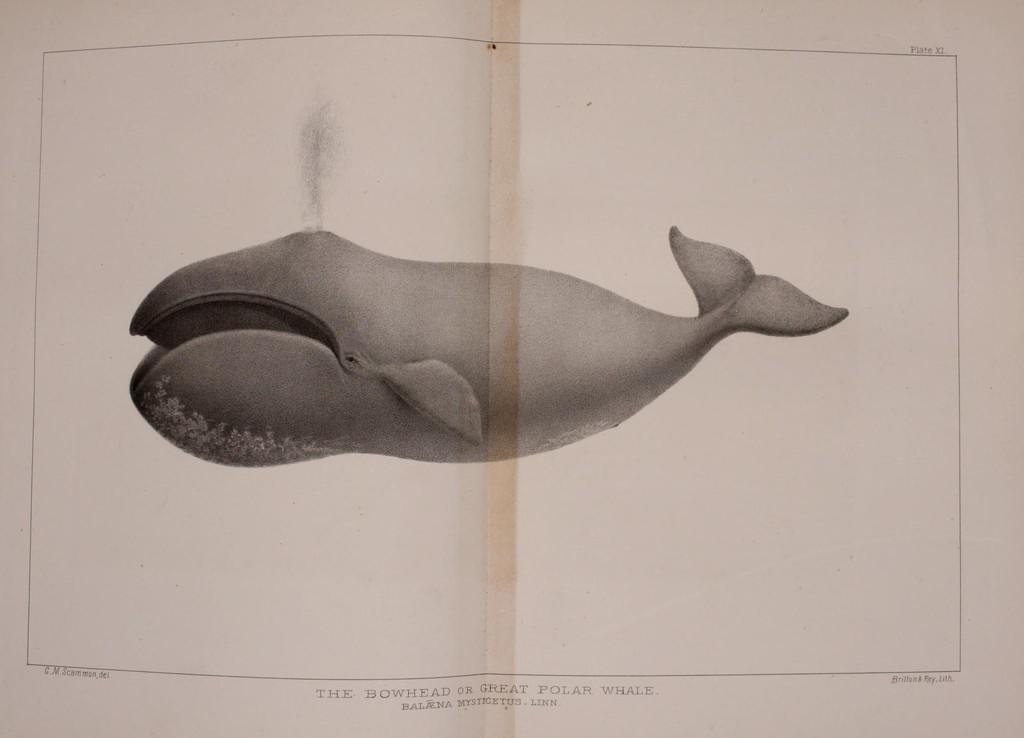Please provide a concise description of this image. There is a whale picture on the paper and at the bottom and top side of the paper they are something written on it 